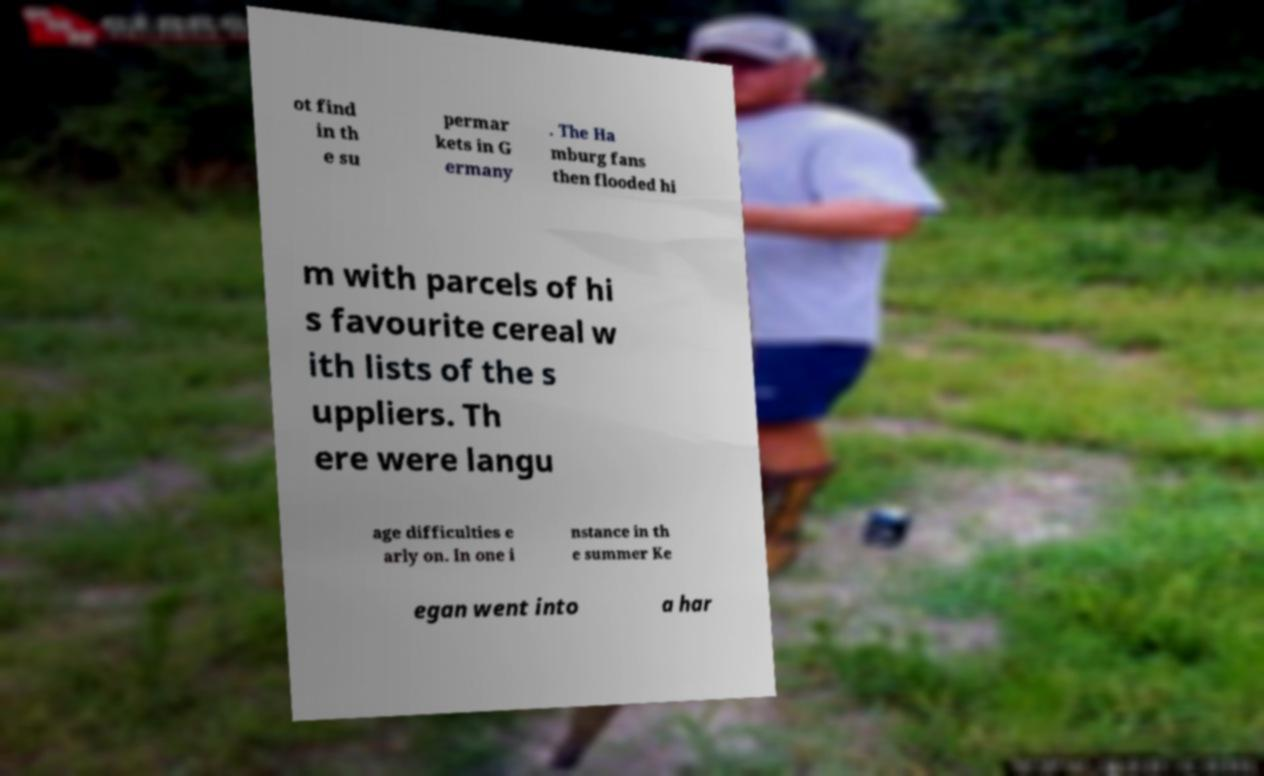For documentation purposes, I need the text within this image transcribed. Could you provide that? ot find in th e su permar kets in G ermany . The Ha mburg fans then flooded hi m with parcels of hi s favourite cereal w ith lists of the s uppliers. Th ere were langu age difficulties e arly on. In one i nstance in th e summer Ke egan went into a har 